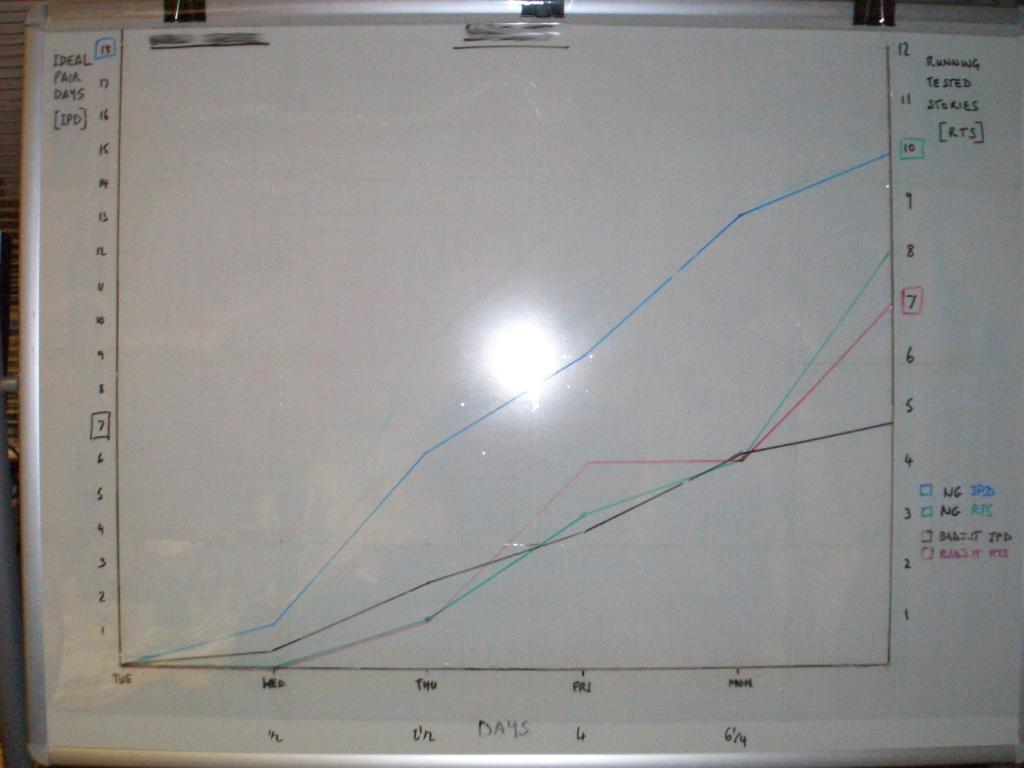What is listed on the y axis?
Make the answer very short. Unanswerable. What does rts stand for?
Provide a short and direct response. Running tested stories. 